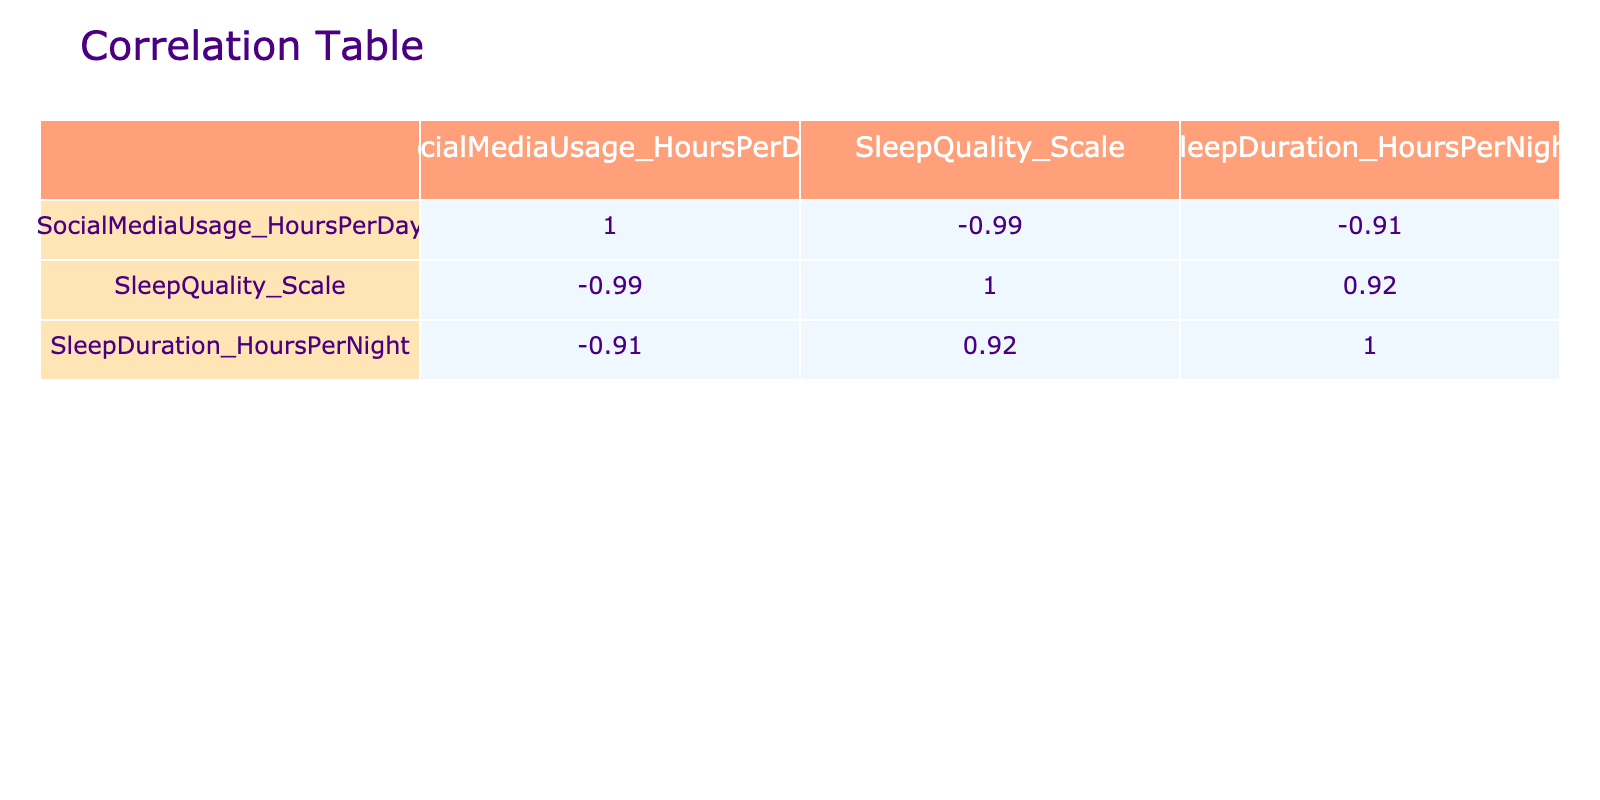What is the correlation coefficient between social media usage and sleep quality? From the correlation table, we look for the value at the intersection of the "SocialMediaUsage_HoursPerDay" row and the "SleepQuality_Scale" column. The value is -0.76, indicating a strong negative correlation between social media usage and sleep quality.
Answer: -0.76 Which student has the highest sleep quality score? We scan the "SleepQuality_Scale" column to find the maximum value, which is 9, associated with Student 5.
Answer: Student 5 What is the average sleep quality score of students who use social media for 4 hours or more per day? First, we identify students using social media for 4 or more hours: Student 2 (4), Student 4 (4), Student 6 (6), Student 7 (7). Their sleep quality scores are 4, 5, 3, and 2. The average is calculated as (4 + 5 + 3 + 2) / 4 = 3.5.
Answer: 3.5 Is there a positive correlation between sleep duration and sleep quality? We check the correlation coefficient between "SleepQuality_Scale" and "SleepDuration_HoursPerNight." The value is 0.79, indicating a strong positive correlation.
Answer: Yes What is the difference in sleep quality between students who use social media for 1 hour and those who use it for 7 hours? We find the sleep quality of Student 5 (1 hour), which is 9, and Student 7 (7 hours), which is 2. The difference is 9 - 2 = 7.
Answer: 7 What is the average sleep duration for all students? We sum the sleep durations of all students: 7 + 5 + 8 + 6 + 9 + 4 + 5 + 6 + 8 + 7 = 66. We then divide by the number of students (10): 66 / 10 = 6.6.
Answer: 6.6 Are there any students who have poor sleep quality (score of 3 or below) while using social media less than 4 hours? Students who use social media less than 4 hours are Student 1 (3 hours, score 6), Student 3 (2 hours, score 8), Student 8 (3 hours, score 7), and Student 9 (2 hours, score 8). None fit the criteria of a score of 3 or below.
Answer: No What is the correlation between social media usage and sleep duration? We find the intersection of "SocialMediaUsage_HoursPerDay" and "SleepDuration_HoursPerNight" in the correlation table, which is -0.52, indicating a moderate negative correlation.
Answer: -0.52 Which student had the lowest social media usage and how did it affect their sleep quality? Student 5 had the lowest social media usage at 1 hour per day with a sleep quality score of 9, indicating a high quality of sleep relative to their usage.
Answer: Student 5, score 9 